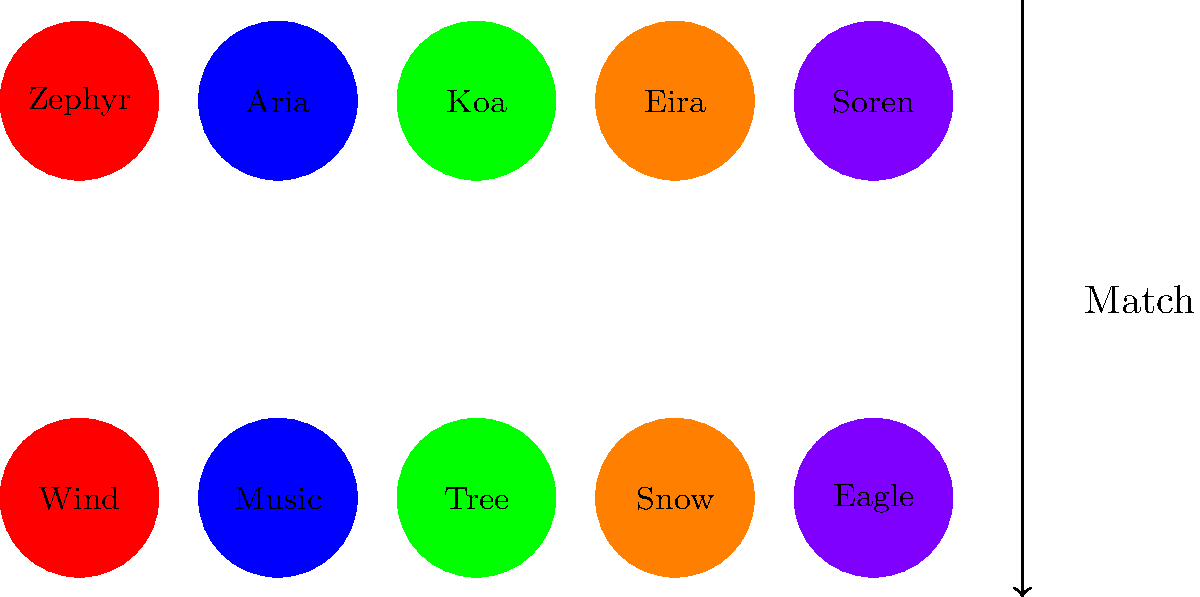Match the unusual names to their corresponding cultural symbols or icons. Which name is associated with the symbol "Snow"? To solve this visual puzzle, we need to follow these steps:

1. Observe that there are five unusual names: Zephyr, Aria, Koa, Eira, and Soren.
2. Notice that there are five corresponding symbols: Wind, Music, Tree, Snow, and Eagle.
3. The colors of the circles containing the names match the colors of the circles containing the symbols.
4. Match each name to its symbol based on the color:
   - Zephyr (red) matches with Wind
   - Aria (blue) matches with Music
   - Koa (green) matches with Tree
   - Eira (orange) matches with Snow
   - Soren (purple) matches with Eagle
5. The question asks specifically about the symbol "Snow".
6. Identify that "Snow" is in an orange circle.
7. Find the name in the orange circle, which is "Eira".

Therefore, the name associated with the symbol "Snow" is Eira.
Answer: Eira 